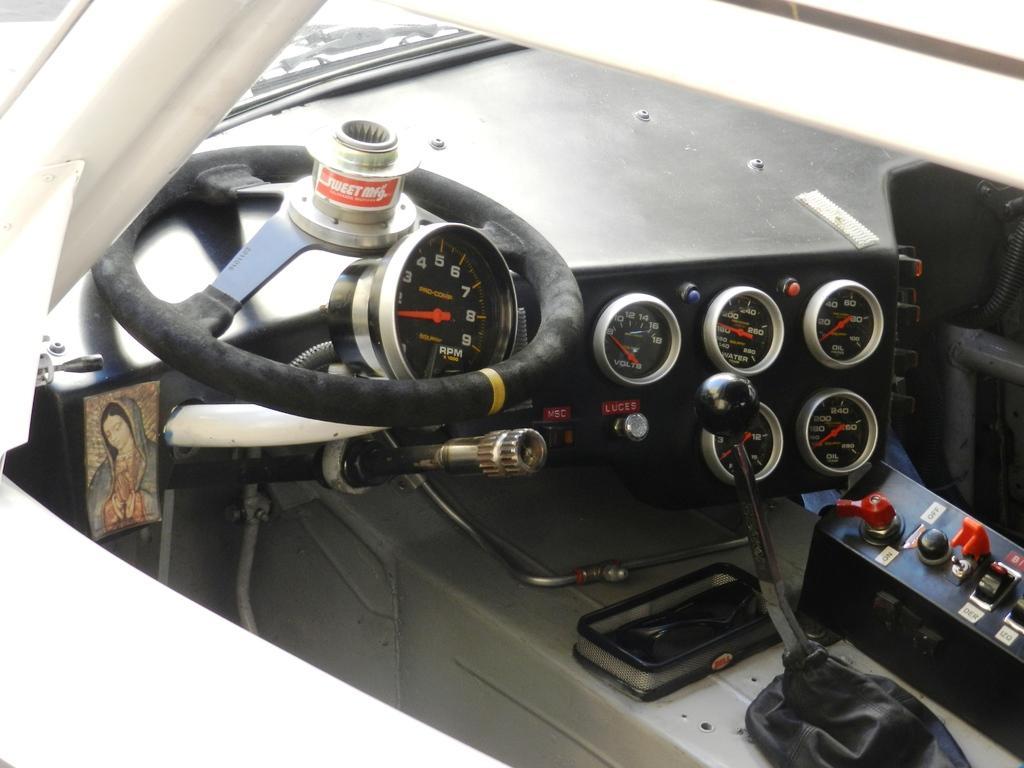In one or two sentences, can you explain what this image depicts? In this image we can see a broken steering. There is a gear rod. There are analog meters. There is a photo. This image is a inside picture of a vehicle. 